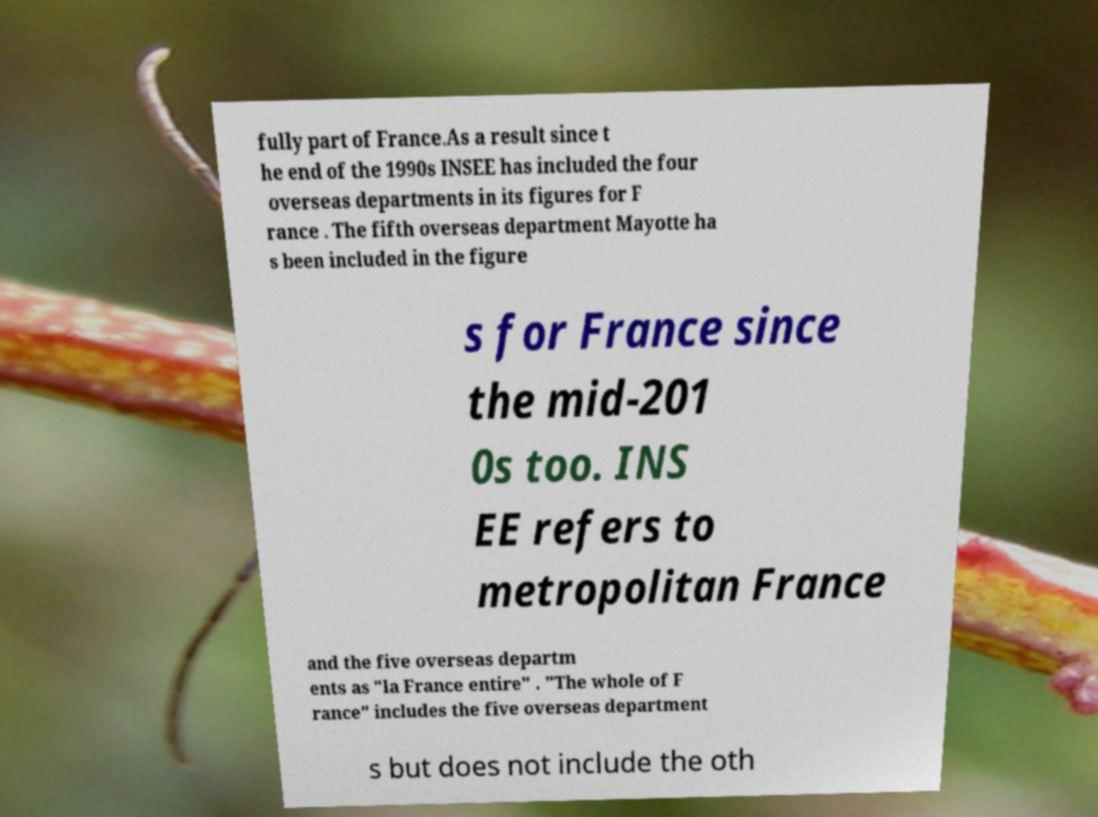I need the written content from this picture converted into text. Can you do that? fully part of France.As a result since t he end of the 1990s INSEE has included the four overseas departments in its figures for F rance . The fifth overseas department Mayotte ha s been included in the figure s for France since the mid-201 0s too. INS EE refers to metropolitan France and the five overseas departm ents as "la France entire" . "The whole of F rance" includes the five overseas department s but does not include the oth 